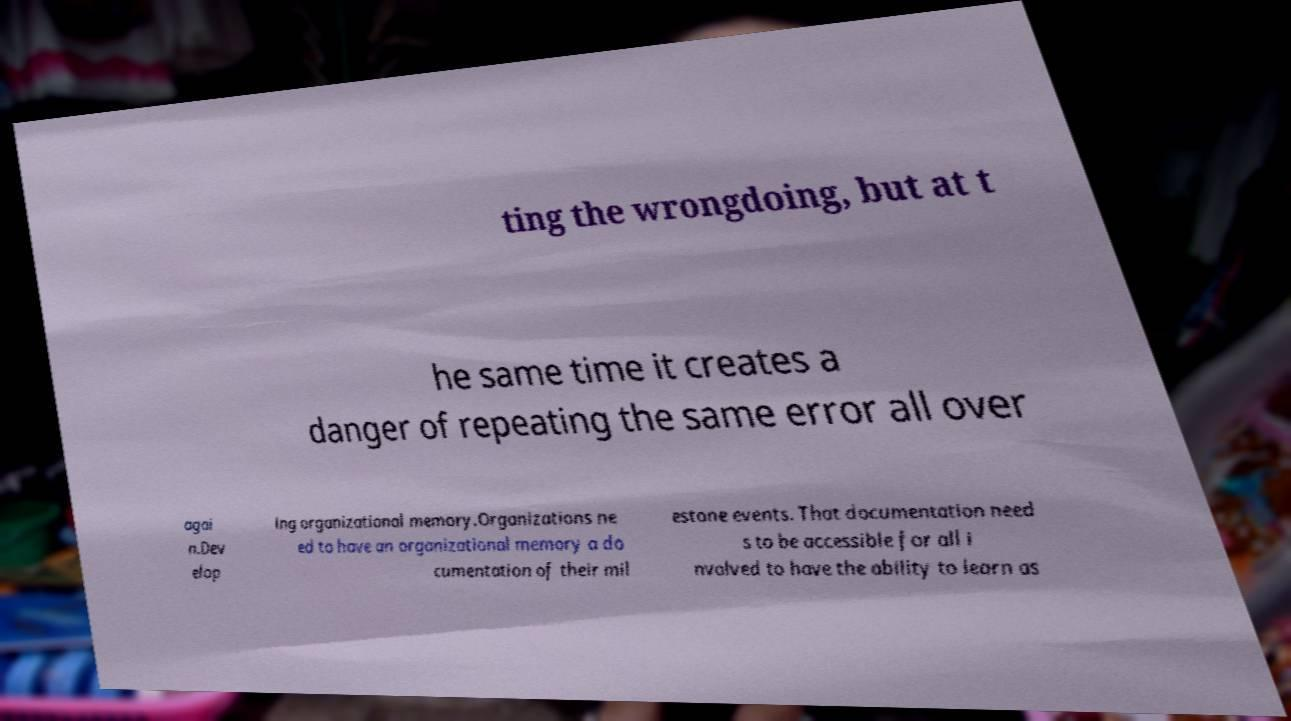What messages or text are displayed in this image? I need them in a readable, typed format. ting the wrongdoing, but at t he same time it creates a danger of repeating the same error all over agai n.Dev elop ing organizational memory.Organizations ne ed to have an organizational memory a do cumentation of their mil estone events. That documentation need s to be accessible for all i nvolved to have the ability to learn as 